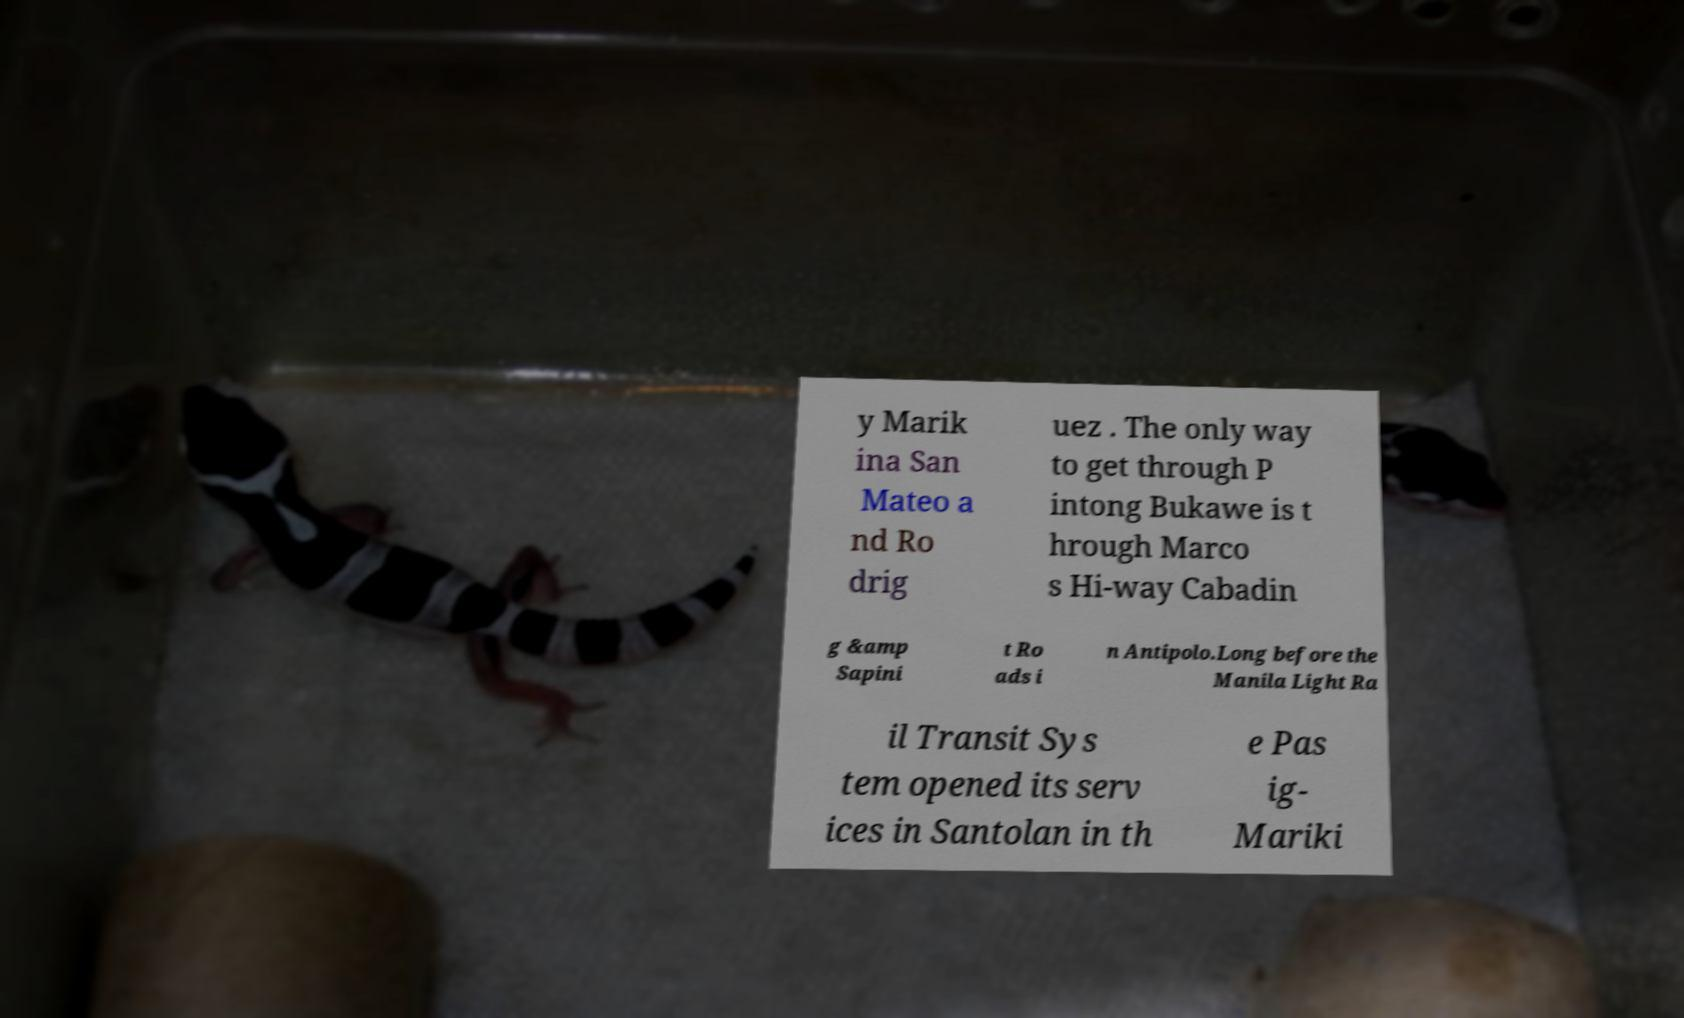Please read and relay the text visible in this image. What does it say? y Marik ina San Mateo a nd Ro drig uez . The only way to get through P intong Bukawe is t hrough Marco s Hi-way Cabadin g &amp Sapini t Ro ads i n Antipolo.Long before the Manila Light Ra il Transit Sys tem opened its serv ices in Santolan in th e Pas ig- Mariki 